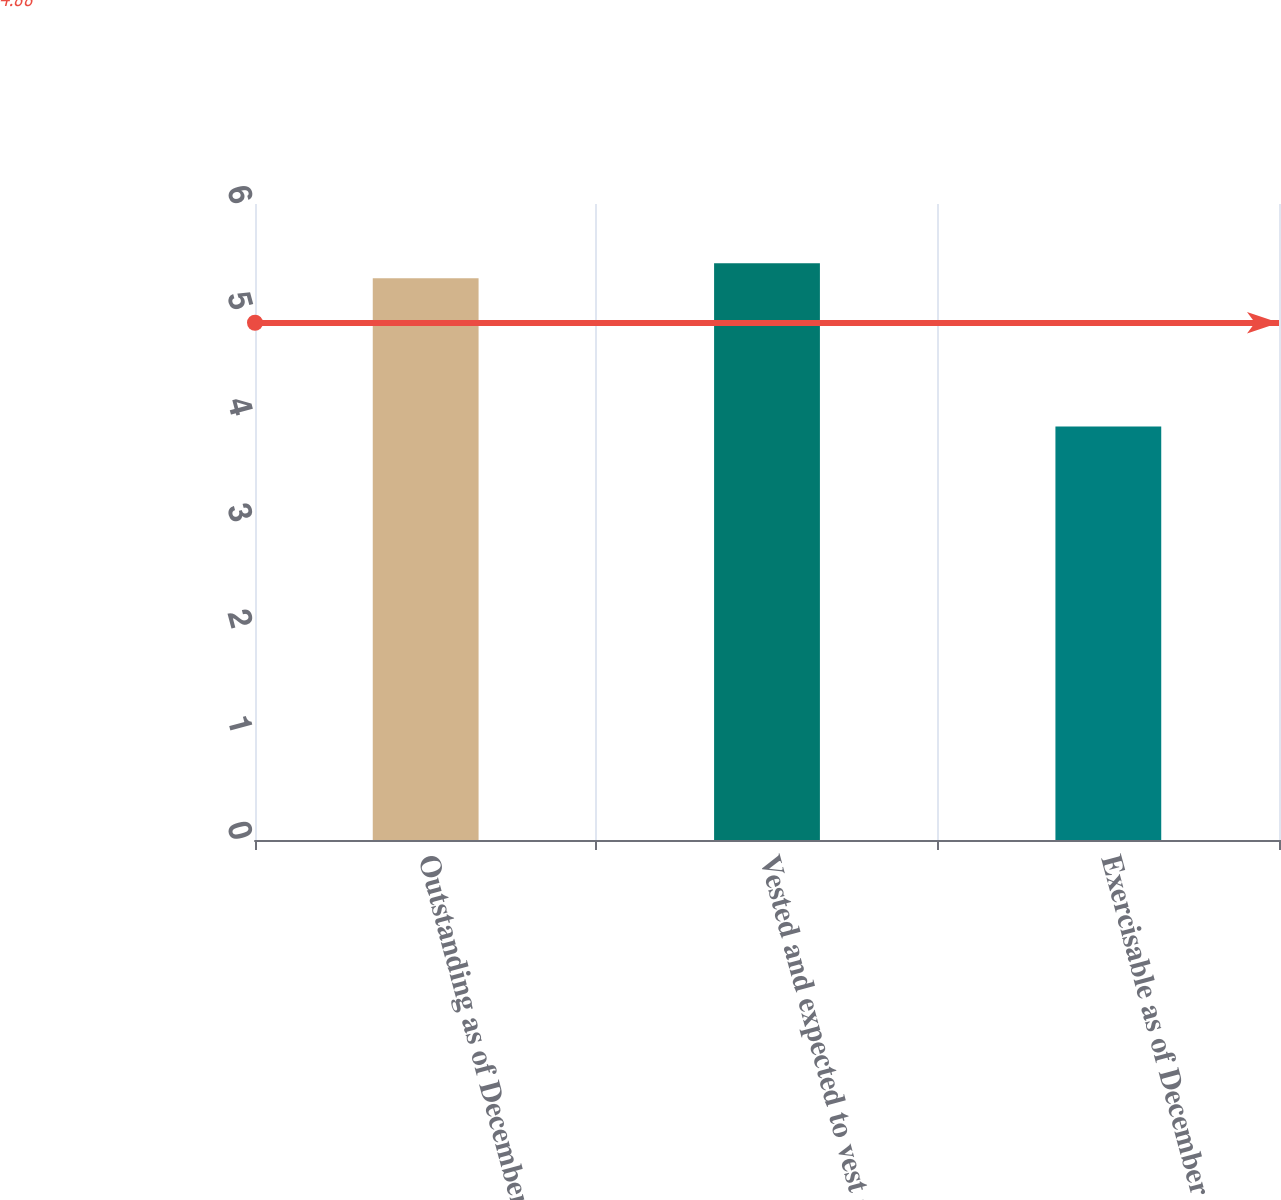<chart> <loc_0><loc_0><loc_500><loc_500><bar_chart><fcel>Outstanding as of December 31<fcel>Vested and expected to vest as<fcel>Exercisable as of December 31<nl><fcel>5.3<fcel>5.44<fcel>3.9<nl></chart> 